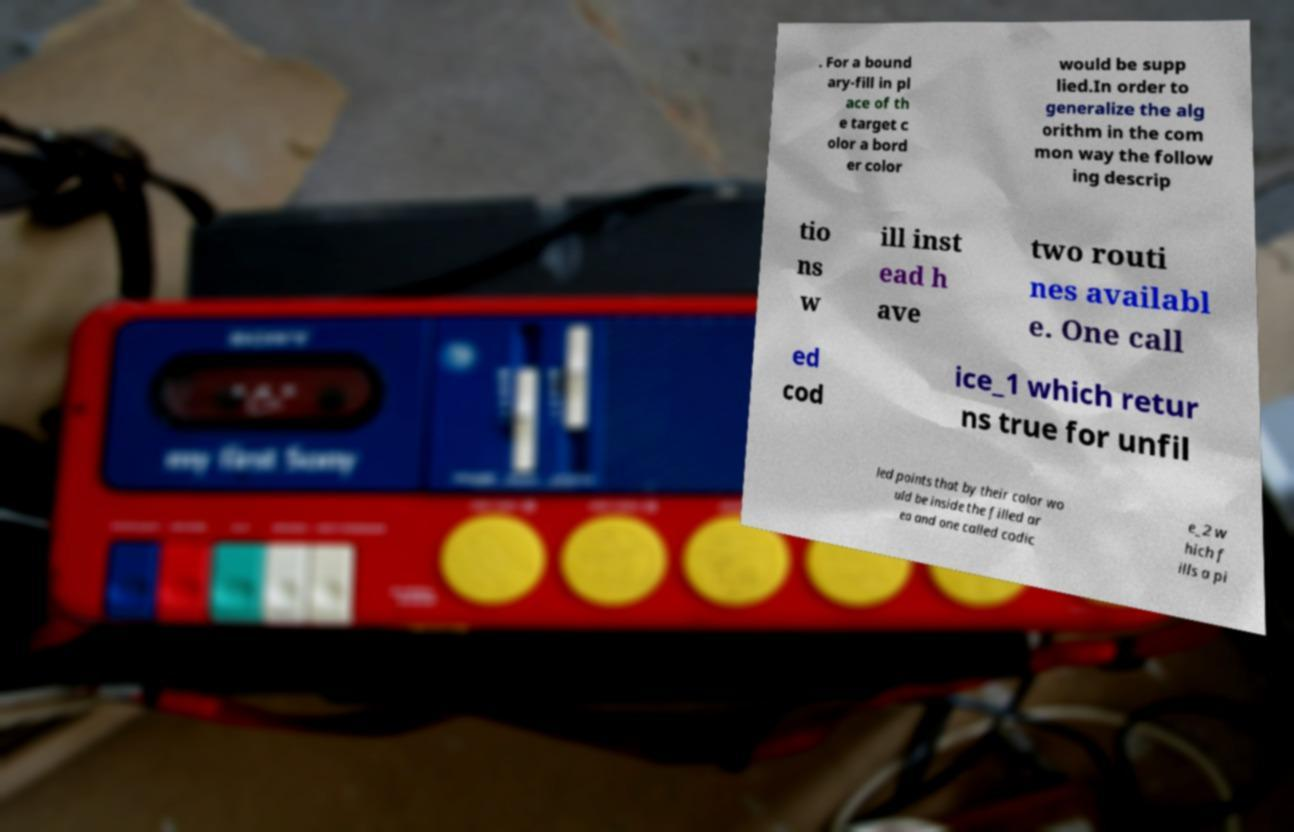Please read and relay the text visible in this image. What does it say? . For a bound ary-fill in pl ace of th e target c olor a bord er color would be supp lied.In order to generalize the alg orithm in the com mon way the follow ing descrip tio ns w ill inst ead h ave two routi nes availabl e. One call ed cod ice_1 which retur ns true for unfil led points that by their color wo uld be inside the filled ar ea and one called codic e_2 w hich f ills a pi 